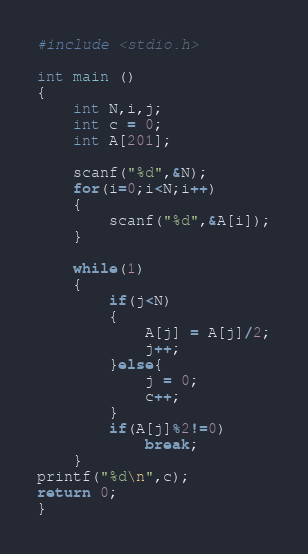<code> <loc_0><loc_0><loc_500><loc_500><_C_>#include <stdio.h>
 
int main () 
{
    int N,i,j;
    int c = 0;
    int A[201];

    scanf("%d",&N);
    for(i=0;i<N;i++)
    {
        scanf("%d",&A[i]);
    }

    while(1)
    {
        if(j<N)
        {
            A[j] = A[j]/2;
            j++;
        }else{
            j = 0;
            c++;
        }
        if(A[j]%2!=0)
            break;
    }
printf("%d\n",c);
return 0;
}</code> 